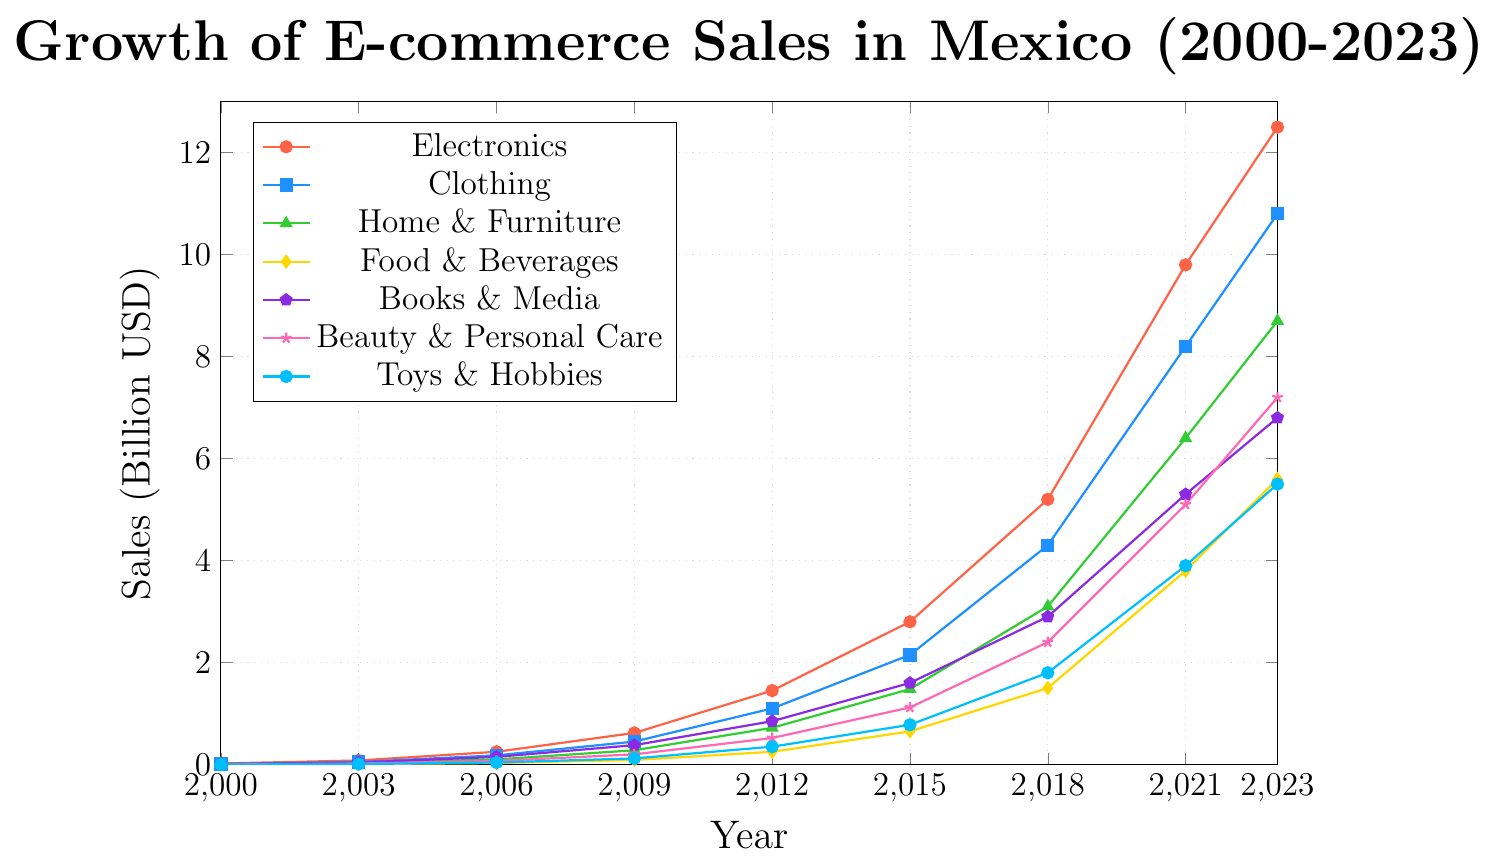Which product category had the highest e-commerce sales in 2023? To determine the highest e-commerce sales in 2023, look at the endpoint (2023) of each product category line. The Electronics line is the highest at 12.50 billion USD.
Answer: Electronics How much did the e-commerce sales for Beauty & Personal Care increase from 2000 to 2023? The sales for Beauty & Personal Care in 2000 were 0.00 USD, and in 2023 they were 7.20 USD. To find the increase, subtract the 2000 value from the 2023 value. 7.20 - 0.00 = 7.20 USD.
Answer: 7.20 billion USD Which product category experienced the fastest growth between 2018 and 2021? Observe the slopes of the lines between the years 2018 and 2021 for all categories. The Electronics category shows the steepest increase, from 5.20 to 9.80, indicating the fastest growth.
Answer: Electronics Which product categories had a sales volume greater than 5 billion USD in 2023? Look at the endpoint (2023) of each product category line. The categories with sales greater than 5 billion USD are Electronics (12.50), Clothing (10.80), Home & Furniture (8.70), Food & Beverages (5.60), Books & Media (6.80), Beauty & Personal Care (7.20), and Toys & Hobbies (5.50).
Answer: Electronics, Clothing, Home & Furniture, Food & Beverages, Books & Media, Beauty & Personal Care, Toys & Hobbies By how much did the sales for Clothing exceed the sales for Food & Beverages in 2023? In 2023, the sales for Clothing were 10.80 billion USD, and for Food & Beverages were 5.60 billion USD. The difference is 10.80 - 5.60 = 5.20 billion USD.
Answer: 5.20 billion USD What was the average e-commerce sales for Books & Media between 2006 and 2023? First, sum the sales values of Books & Media for the years 2006, 2009, 2012, 2015, 2018, 2021, and 2023: 0.15 + 0.38 + 0.85 + 1.60 + 2.90 + 5.30 + 6.80 = 18.98. Then, divide by the number of years: 18.98 / 7 = 2.71.
Answer: 2.71 billion USD Which product category had the smallest increase between 2000 and 2009? Compare the sales values from 2000 to 2009 for all categories: Electronics (0.60), Clothing (0.44), Home & Furniture (0.27), Food & Beverages (0.09), Books & Media (0.37), Beauty & Personal Care (0.20), Toys & Hobbies (0.12). Food & Beverages show the smallest increase.
Answer: Food & Beverages What is the total e-commerce sales for all categories in 2021? Add the sales values for each category in 2021: Electronics (9.80), Clothing (8.20), Home & Furniture (6.40), Food & Beverages (3.80), Books & Media (5.30), Beauty & Personal Care (5.10), Toys & Hobbies (3.90). Total = 9.80 + 8.20 + 6.40 + 3.80 + 5.30 + 5.10 + 3.90 = 42.50.
Answer: 42.50 billion USD 